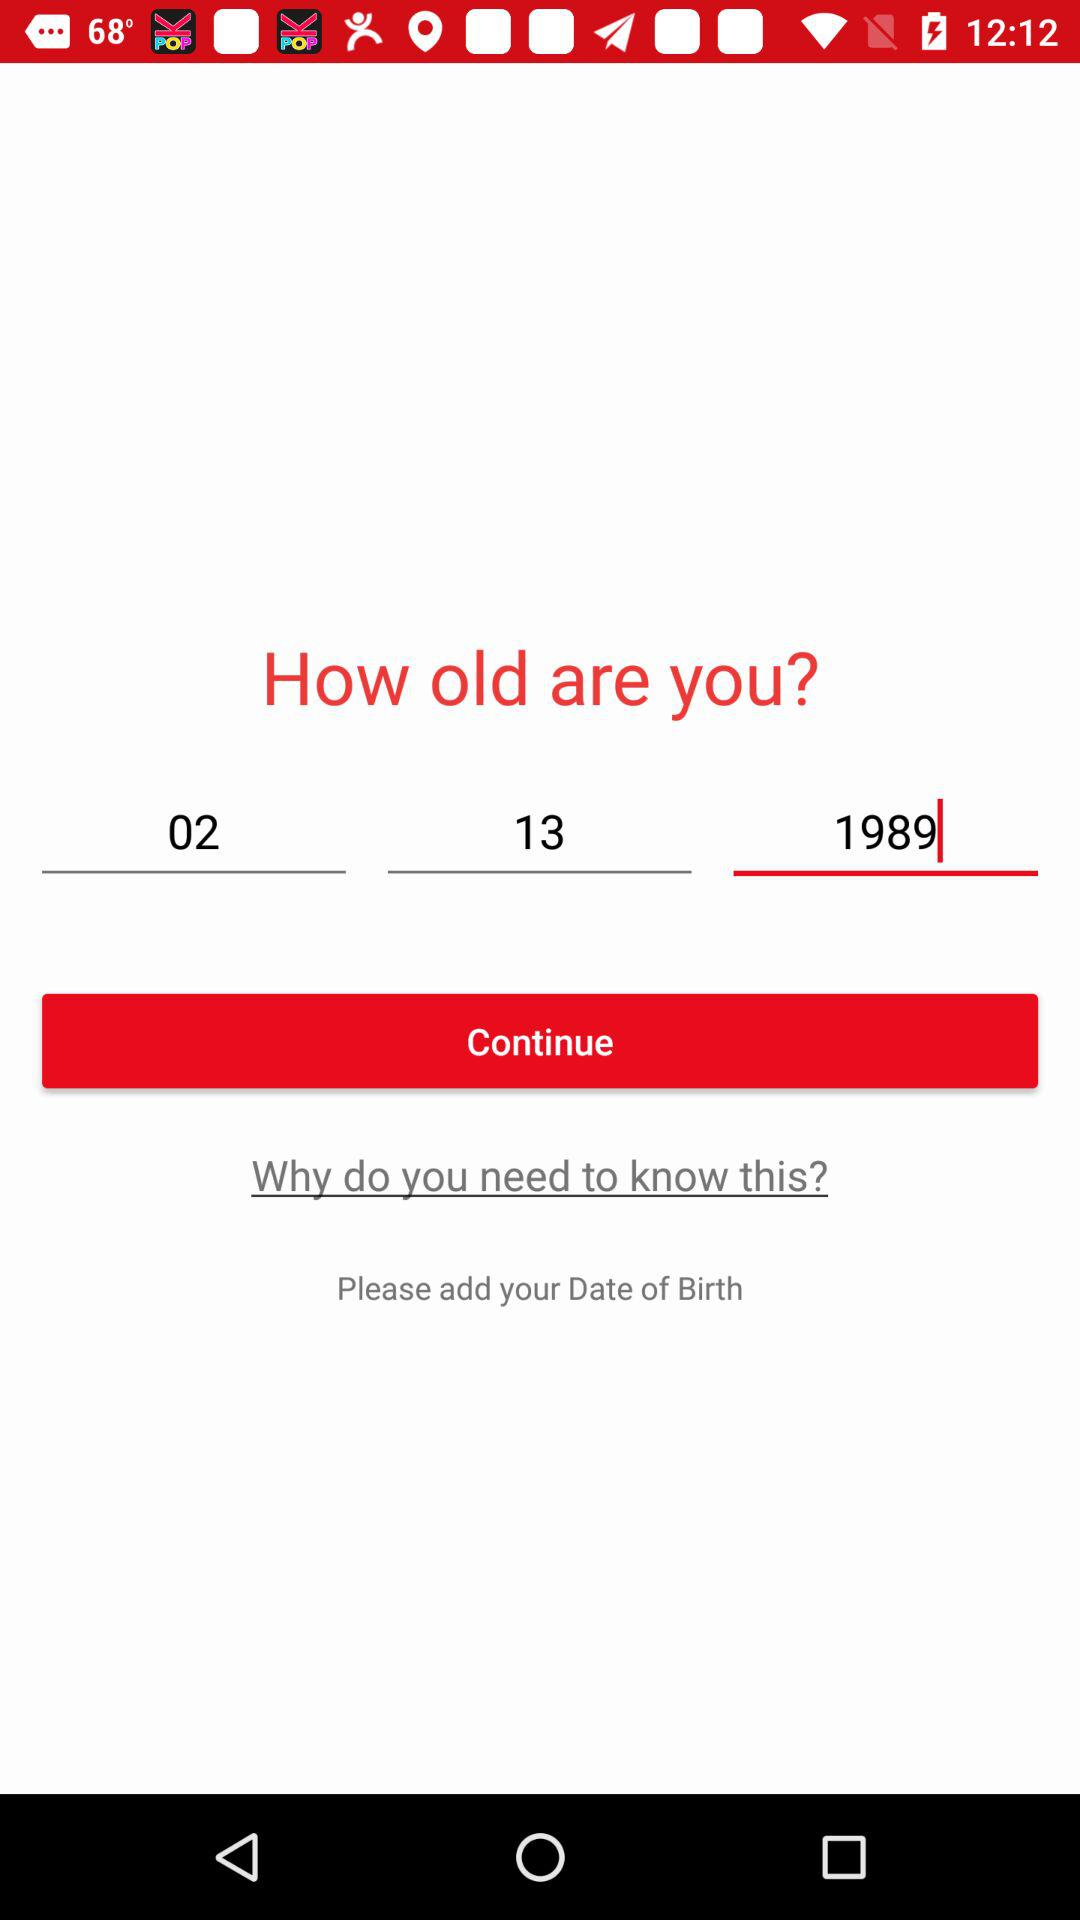What is the selected day?
When the provided information is insufficient, respond with <no answer>. <no answer> 